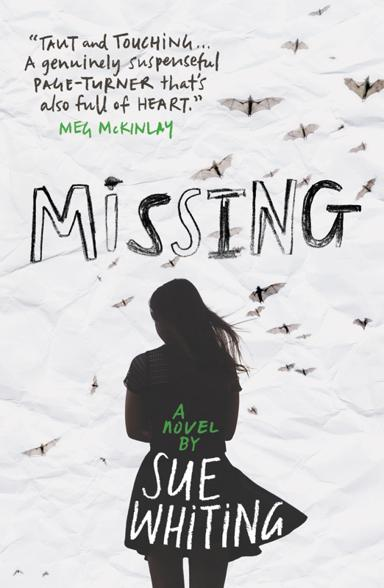What is the name of the novel mentioned in the image? The novel depicted in the image is titled 'Missing,' and it is authored by Sue Whiting. On the cover, you can see the author's name and the title prominently displayed, indicating the emotional journey the story promises to take its readers on. 